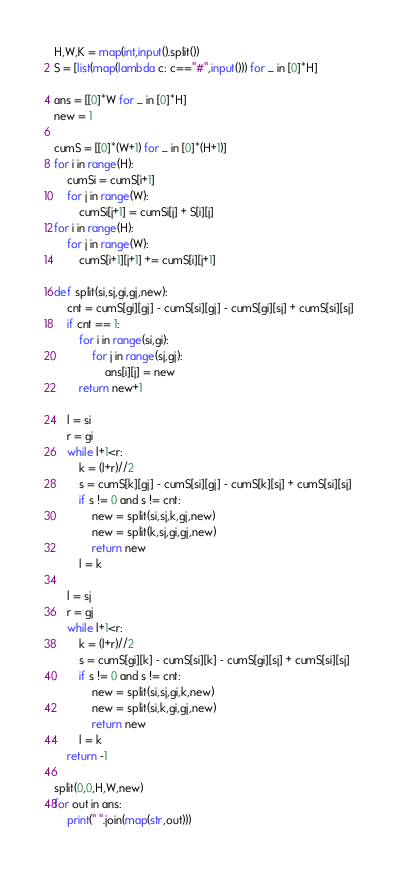<code> <loc_0><loc_0><loc_500><loc_500><_Python_>H,W,K = map(int,input().split())
S = [list(map(lambda c: c=="#",input())) for _ in [0]*H]

ans = [[0]*W for _ in [0]*H]
new = 1

cumS = [[0]*(W+1) for _ in [0]*(H+1)]
for i in range(H):
    cumSi = cumS[i+1]
    for j in range(W):
        cumSi[j+1] = cumSi[j] + S[i][j]
for i in range(H):
    for j in range(W):
        cumS[i+1][j+1] += cumS[i][j+1]

def split(si,sj,gi,gj,new):
    cnt = cumS[gi][gj] - cumS[si][gj] - cumS[gi][sj] + cumS[si][sj]
    if cnt == 1:
        for i in range(si,gi):
            for j in range(sj,gj):
                ans[i][j] = new
        return new+1
    
    l = si
    r = gi
    while l+1<r:
        k = (l+r)//2
        s = cumS[k][gj] - cumS[si][gj] - cumS[k][sj] + cumS[si][sj]
        if s != 0 and s != cnt:
            new = split(si,sj,k,gj,new)
            new = split(k,sj,gi,gj,new)
            return new
        l = k
    
    l = sj
    r = gj
    while l+1<r:
        k = (l+r)//2
        s = cumS[gi][k] - cumS[si][k] - cumS[gi][sj] + cumS[si][sj]
        if s != 0 and s != cnt:
            new = split(si,sj,gi,k,new)
            new = split(si,k,gi,gj,new)
            return new
        l = k
    return -1

split(0,0,H,W,new)
for out in ans:
    print(" ".join(map(str,out)))</code> 